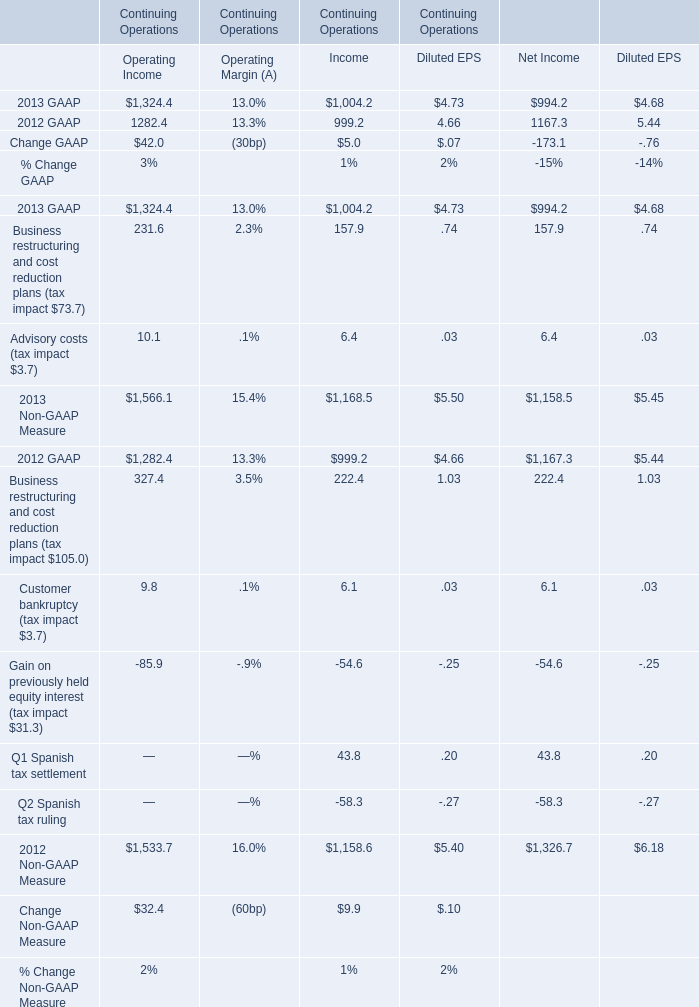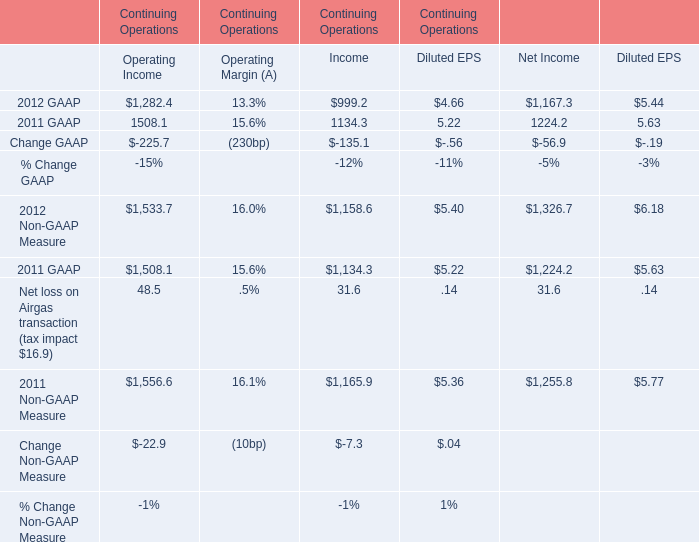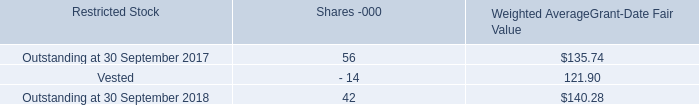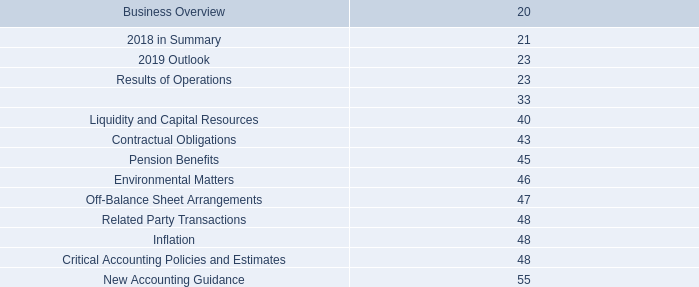What is the growing rate of GAAP Operating Income in the year with the most Non-GAAP Measure Operating Income? 
Computations: ((1324.4 - 1282.4) / 1282.4)
Answer: 0.03275. 